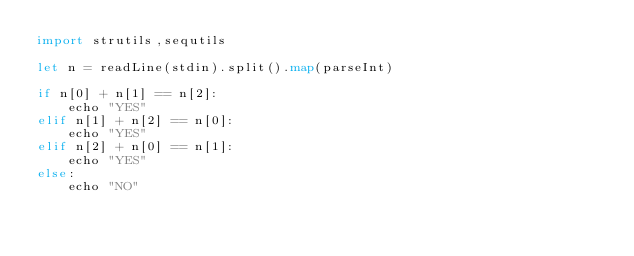Convert code to text. <code><loc_0><loc_0><loc_500><loc_500><_Nim_>import strutils,sequtils

let n = readLine(stdin).split().map(parseInt)

if n[0] + n[1] == n[2]:
    echo "YES"
elif n[1] + n[2] == n[0]:
    echo "YES"
elif n[2] + n[0] == n[1]:
    echo "YES"
else:
    echo "NO"</code> 